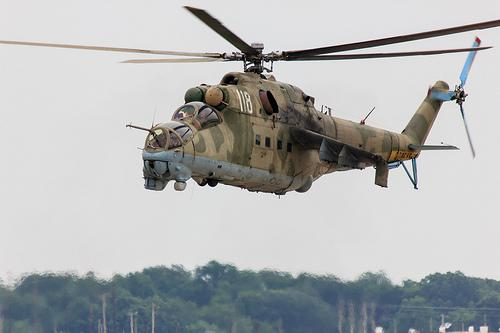Question: what pattern is the paint on the helicopter?
Choices:
A. Striped.
B. Checkered.
C. Polka-dot.
D. Camouflage.
Answer with the letter. Answer: D Question: where is the helicopter?
Choices:
A. Top of building.
B. On ground.
C. On hill.
D. In the sky.
Answer with the letter. Answer: D 